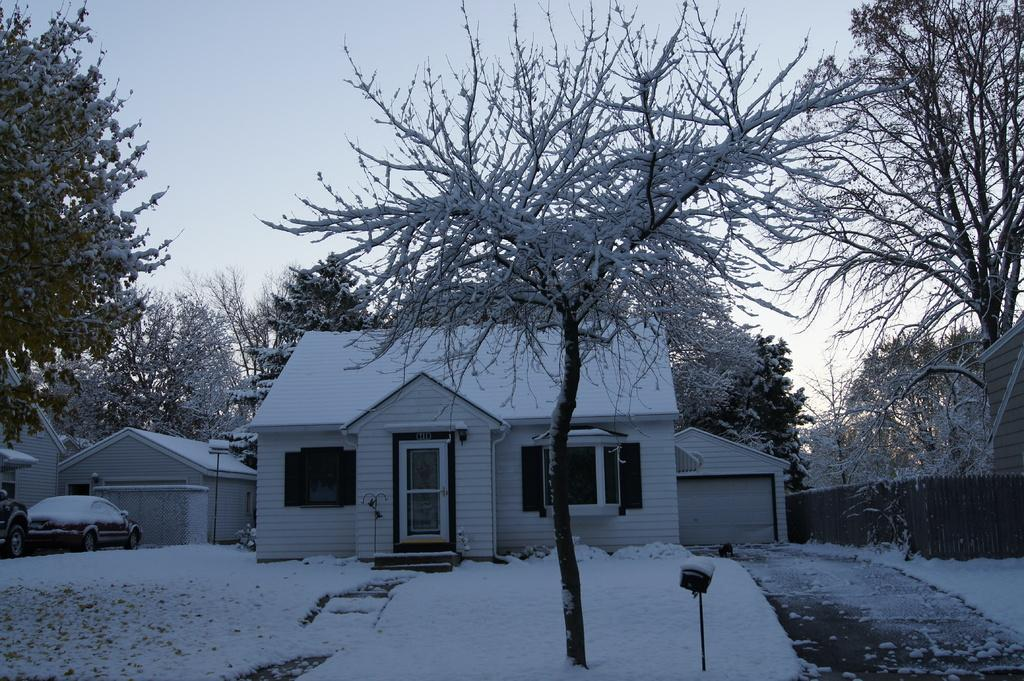What is covering the ground in the foreground of the image? There is snow on the ground in the foreground of the image. What type of natural elements can be seen in the image? Trees are visible in the image. What type of structures are present in the image? There are houses in the image. How many vehicles can be seen in the image? Two vehicles are present in the image. What is visible in the background of the image? The sky is visible in the image. What type of bird is using the scissors to cut the support in the image? There is no bird, scissors, or support present in the image. 